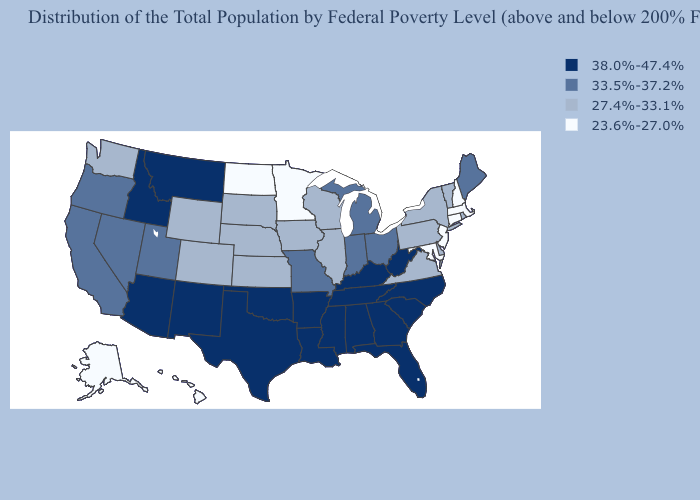Name the states that have a value in the range 33.5%-37.2%?
Quick response, please. California, Indiana, Maine, Michigan, Missouri, Nevada, Ohio, Oregon, Utah. Does New Mexico have the highest value in the West?
Short answer required. Yes. What is the value of Maine?
Short answer required. 33.5%-37.2%. What is the highest value in the Northeast ?
Give a very brief answer. 33.5%-37.2%. Name the states that have a value in the range 38.0%-47.4%?
Quick response, please. Alabama, Arizona, Arkansas, Florida, Georgia, Idaho, Kentucky, Louisiana, Mississippi, Montana, New Mexico, North Carolina, Oklahoma, South Carolina, Tennessee, Texas, West Virginia. Name the states that have a value in the range 38.0%-47.4%?
Short answer required. Alabama, Arizona, Arkansas, Florida, Georgia, Idaho, Kentucky, Louisiana, Mississippi, Montana, New Mexico, North Carolina, Oklahoma, South Carolina, Tennessee, Texas, West Virginia. Name the states that have a value in the range 23.6%-27.0%?
Give a very brief answer. Alaska, Connecticut, Hawaii, Maryland, Massachusetts, Minnesota, New Hampshire, New Jersey, North Dakota. Among the states that border Utah , which have the highest value?
Quick response, please. Arizona, Idaho, New Mexico. Does South Carolina have the lowest value in the USA?
Concise answer only. No. What is the value of Michigan?
Be succinct. 33.5%-37.2%. Does Kentucky have the highest value in the South?
Concise answer only. Yes. Which states have the lowest value in the USA?
Be succinct. Alaska, Connecticut, Hawaii, Maryland, Massachusetts, Minnesota, New Hampshire, New Jersey, North Dakota. What is the value of Indiana?
Answer briefly. 33.5%-37.2%. Does Minnesota have the lowest value in the USA?
Short answer required. Yes. Which states have the lowest value in the Northeast?
Answer briefly. Connecticut, Massachusetts, New Hampshire, New Jersey. 